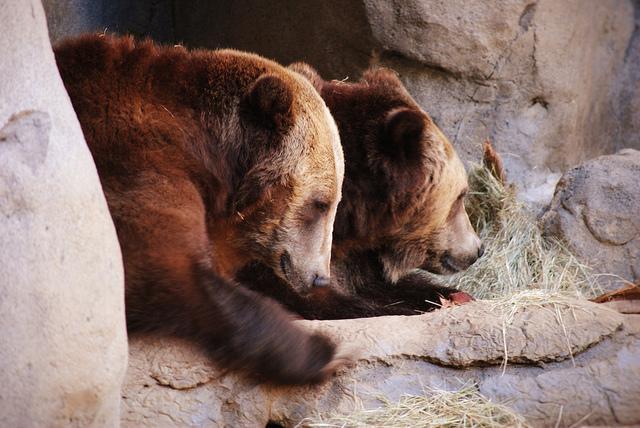How many bears are there?
Give a very brief answer. 2. How many cows are there?
Give a very brief answer. 0. 